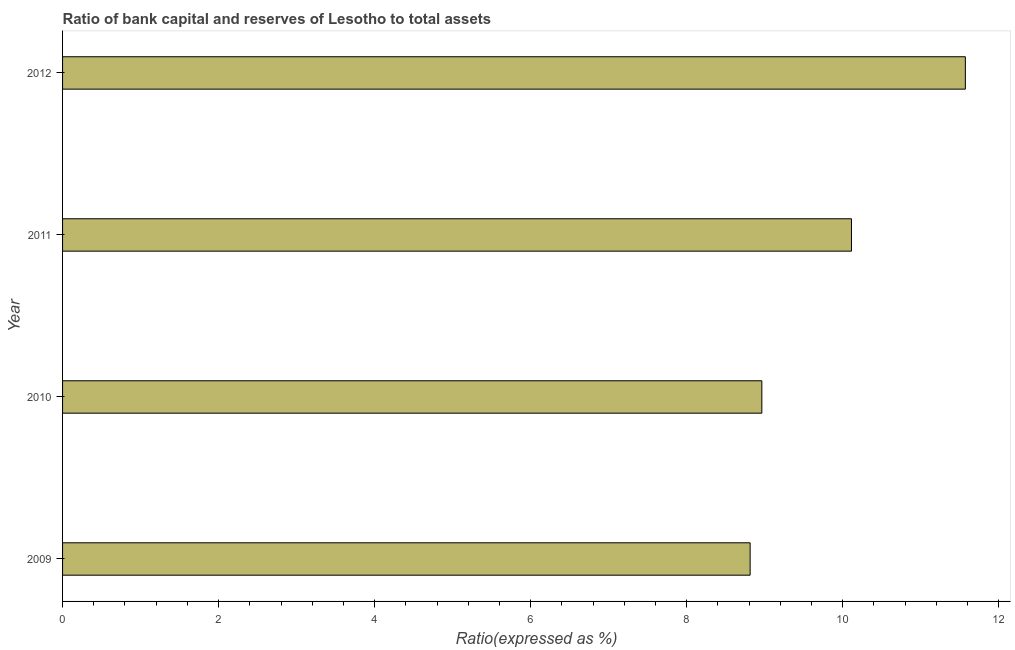Does the graph contain any zero values?
Keep it short and to the point. No. What is the title of the graph?
Provide a succinct answer. Ratio of bank capital and reserves of Lesotho to total assets. What is the label or title of the X-axis?
Ensure brevity in your answer.  Ratio(expressed as %). What is the label or title of the Y-axis?
Offer a terse response. Year. What is the bank capital to assets ratio in 2012?
Provide a short and direct response. 11.57. Across all years, what is the maximum bank capital to assets ratio?
Your answer should be compact. 11.57. Across all years, what is the minimum bank capital to assets ratio?
Your answer should be very brief. 8.81. What is the sum of the bank capital to assets ratio?
Provide a succinct answer. 39.46. What is the difference between the bank capital to assets ratio in 2009 and 2012?
Your answer should be compact. -2.76. What is the average bank capital to assets ratio per year?
Provide a succinct answer. 9.87. What is the median bank capital to assets ratio?
Your response must be concise. 9.54. What is the ratio of the bank capital to assets ratio in 2010 to that in 2012?
Offer a very short reply. 0.78. Is the bank capital to assets ratio in 2009 less than that in 2010?
Provide a short and direct response. Yes. What is the difference between the highest and the second highest bank capital to assets ratio?
Give a very brief answer. 1.46. Is the sum of the bank capital to assets ratio in 2009 and 2012 greater than the maximum bank capital to assets ratio across all years?
Provide a short and direct response. Yes. What is the difference between the highest and the lowest bank capital to assets ratio?
Provide a succinct answer. 2.76. Are all the bars in the graph horizontal?
Make the answer very short. Yes. How many years are there in the graph?
Your response must be concise. 4. What is the difference between two consecutive major ticks on the X-axis?
Provide a short and direct response. 2. What is the Ratio(expressed as %) in 2009?
Give a very brief answer. 8.81. What is the Ratio(expressed as %) in 2010?
Offer a terse response. 8.96. What is the Ratio(expressed as %) of 2011?
Ensure brevity in your answer.  10.11. What is the Ratio(expressed as %) of 2012?
Give a very brief answer. 11.57. What is the difference between the Ratio(expressed as %) in 2009 and 2010?
Provide a succinct answer. -0.15. What is the difference between the Ratio(expressed as %) in 2009 and 2011?
Make the answer very short. -1.3. What is the difference between the Ratio(expressed as %) in 2009 and 2012?
Give a very brief answer. -2.76. What is the difference between the Ratio(expressed as %) in 2010 and 2011?
Your answer should be very brief. -1.15. What is the difference between the Ratio(expressed as %) in 2010 and 2012?
Keep it short and to the point. -2.61. What is the difference between the Ratio(expressed as %) in 2011 and 2012?
Your response must be concise. -1.46. What is the ratio of the Ratio(expressed as %) in 2009 to that in 2010?
Offer a terse response. 0.98. What is the ratio of the Ratio(expressed as %) in 2009 to that in 2011?
Give a very brief answer. 0.87. What is the ratio of the Ratio(expressed as %) in 2009 to that in 2012?
Ensure brevity in your answer.  0.76. What is the ratio of the Ratio(expressed as %) in 2010 to that in 2011?
Make the answer very short. 0.89. What is the ratio of the Ratio(expressed as %) in 2010 to that in 2012?
Your answer should be very brief. 0.78. What is the ratio of the Ratio(expressed as %) in 2011 to that in 2012?
Ensure brevity in your answer.  0.87. 